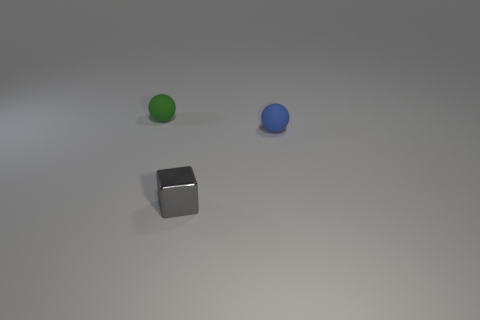What material is the block that is the same size as the blue object?
Offer a terse response. Metal. Are there any other things that are the same material as the small gray object?
Ensure brevity in your answer.  No. What color is the rubber ball to the right of the metallic object?
Your response must be concise. Blue. Is the number of gray objects on the left side of the tiny gray block the same as the number of small yellow objects?
Offer a terse response. Yes. How many other objects are there of the same shape as the small gray metal thing?
Provide a short and direct response. 0. There is a blue matte ball; how many gray metal things are on the right side of it?
Your response must be concise. 0. There is a thing that is both in front of the green matte sphere and on the left side of the tiny blue matte sphere; what size is it?
Your answer should be compact. Small. Are any blue objects visible?
Offer a very short reply. Yes. What number of other objects are there of the same size as the blue thing?
Keep it short and to the point. 2. The other matte thing that is the same shape as the tiny blue object is what size?
Provide a succinct answer. Small. 